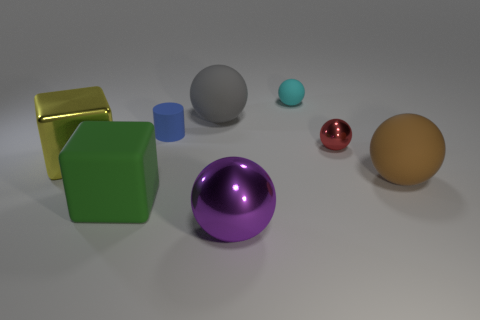Subtract all gray balls. How many balls are left? 4 Subtract all small metallic spheres. How many spheres are left? 4 Subtract all gray spheres. Subtract all purple cubes. How many spheres are left? 4 Add 1 rubber things. How many objects exist? 9 Subtract all blocks. How many objects are left? 6 Subtract all large green things. Subtract all brown spheres. How many objects are left? 6 Add 6 brown spheres. How many brown spheres are left? 7 Add 8 shiny balls. How many shiny balls exist? 10 Subtract 0 green cylinders. How many objects are left? 8 